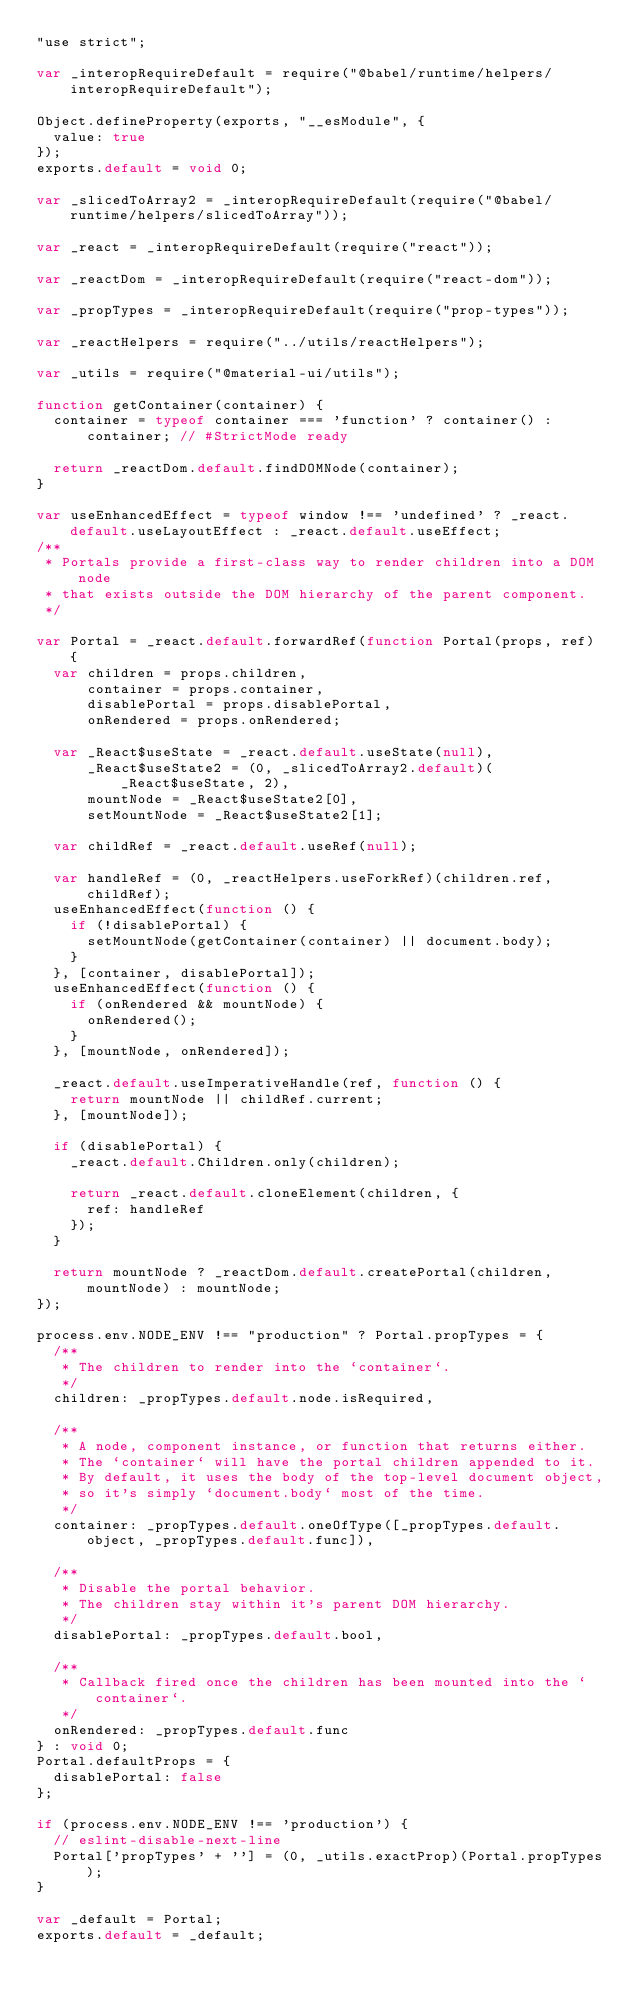<code> <loc_0><loc_0><loc_500><loc_500><_JavaScript_>"use strict";

var _interopRequireDefault = require("@babel/runtime/helpers/interopRequireDefault");

Object.defineProperty(exports, "__esModule", {
  value: true
});
exports.default = void 0;

var _slicedToArray2 = _interopRequireDefault(require("@babel/runtime/helpers/slicedToArray"));

var _react = _interopRequireDefault(require("react"));

var _reactDom = _interopRequireDefault(require("react-dom"));

var _propTypes = _interopRequireDefault(require("prop-types"));

var _reactHelpers = require("../utils/reactHelpers");

var _utils = require("@material-ui/utils");

function getContainer(container) {
  container = typeof container === 'function' ? container() : container; // #StrictMode ready

  return _reactDom.default.findDOMNode(container);
}

var useEnhancedEffect = typeof window !== 'undefined' ? _react.default.useLayoutEffect : _react.default.useEffect;
/**
 * Portals provide a first-class way to render children into a DOM node
 * that exists outside the DOM hierarchy of the parent component.
 */

var Portal = _react.default.forwardRef(function Portal(props, ref) {
  var children = props.children,
      container = props.container,
      disablePortal = props.disablePortal,
      onRendered = props.onRendered;

  var _React$useState = _react.default.useState(null),
      _React$useState2 = (0, _slicedToArray2.default)(_React$useState, 2),
      mountNode = _React$useState2[0],
      setMountNode = _React$useState2[1];

  var childRef = _react.default.useRef(null);

  var handleRef = (0, _reactHelpers.useForkRef)(children.ref, childRef);
  useEnhancedEffect(function () {
    if (!disablePortal) {
      setMountNode(getContainer(container) || document.body);
    }
  }, [container, disablePortal]);
  useEnhancedEffect(function () {
    if (onRendered && mountNode) {
      onRendered();
    }
  }, [mountNode, onRendered]);

  _react.default.useImperativeHandle(ref, function () {
    return mountNode || childRef.current;
  }, [mountNode]);

  if (disablePortal) {
    _react.default.Children.only(children);

    return _react.default.cloneElement(children, {
      ref: handleRef
    });
  }

  return mountNode ? _reactDom.default.createPortal(children, mountNode) : mountNode;
});

process.env.NODE_ENV !== "production" ? Portal.propTypes = {
  /**
   * The children to render into the `container`.
   */
  children: _propTypes.default.node.isRequired,

  /**
   * A node, component instance, or function that returns either.
   * The `container` will have the portal children appended to it.
   * By default, it uses the body of the top-level document object,
   * so it's simply `document.body` most of the time.
   */
  container: _propTypes.default.oneOfType([_propTypes.default.object, _propTypes.default.func]),

  /**
   * Disable the portal behavior.
   * The children stay within it's parent DOM hierarchy.
   */
  disablePortal: _propTypes.default.bool,

  /**
   * Callback fired once the children has been mounted into the `container`.
   */
  onRendered: _propTypes.default.func
} : void 0;
Portal.defaultProps = {
  disablePortal: false
};

if (process.env.NODE_ENV !== 'production') {
  // eslint-disable-next-line
  Portal['propTypes' + ''] = (0, _utils.exactProp)(Portal.propTypes);
}

var _default = Portal;
exports.default = _default;</code> 